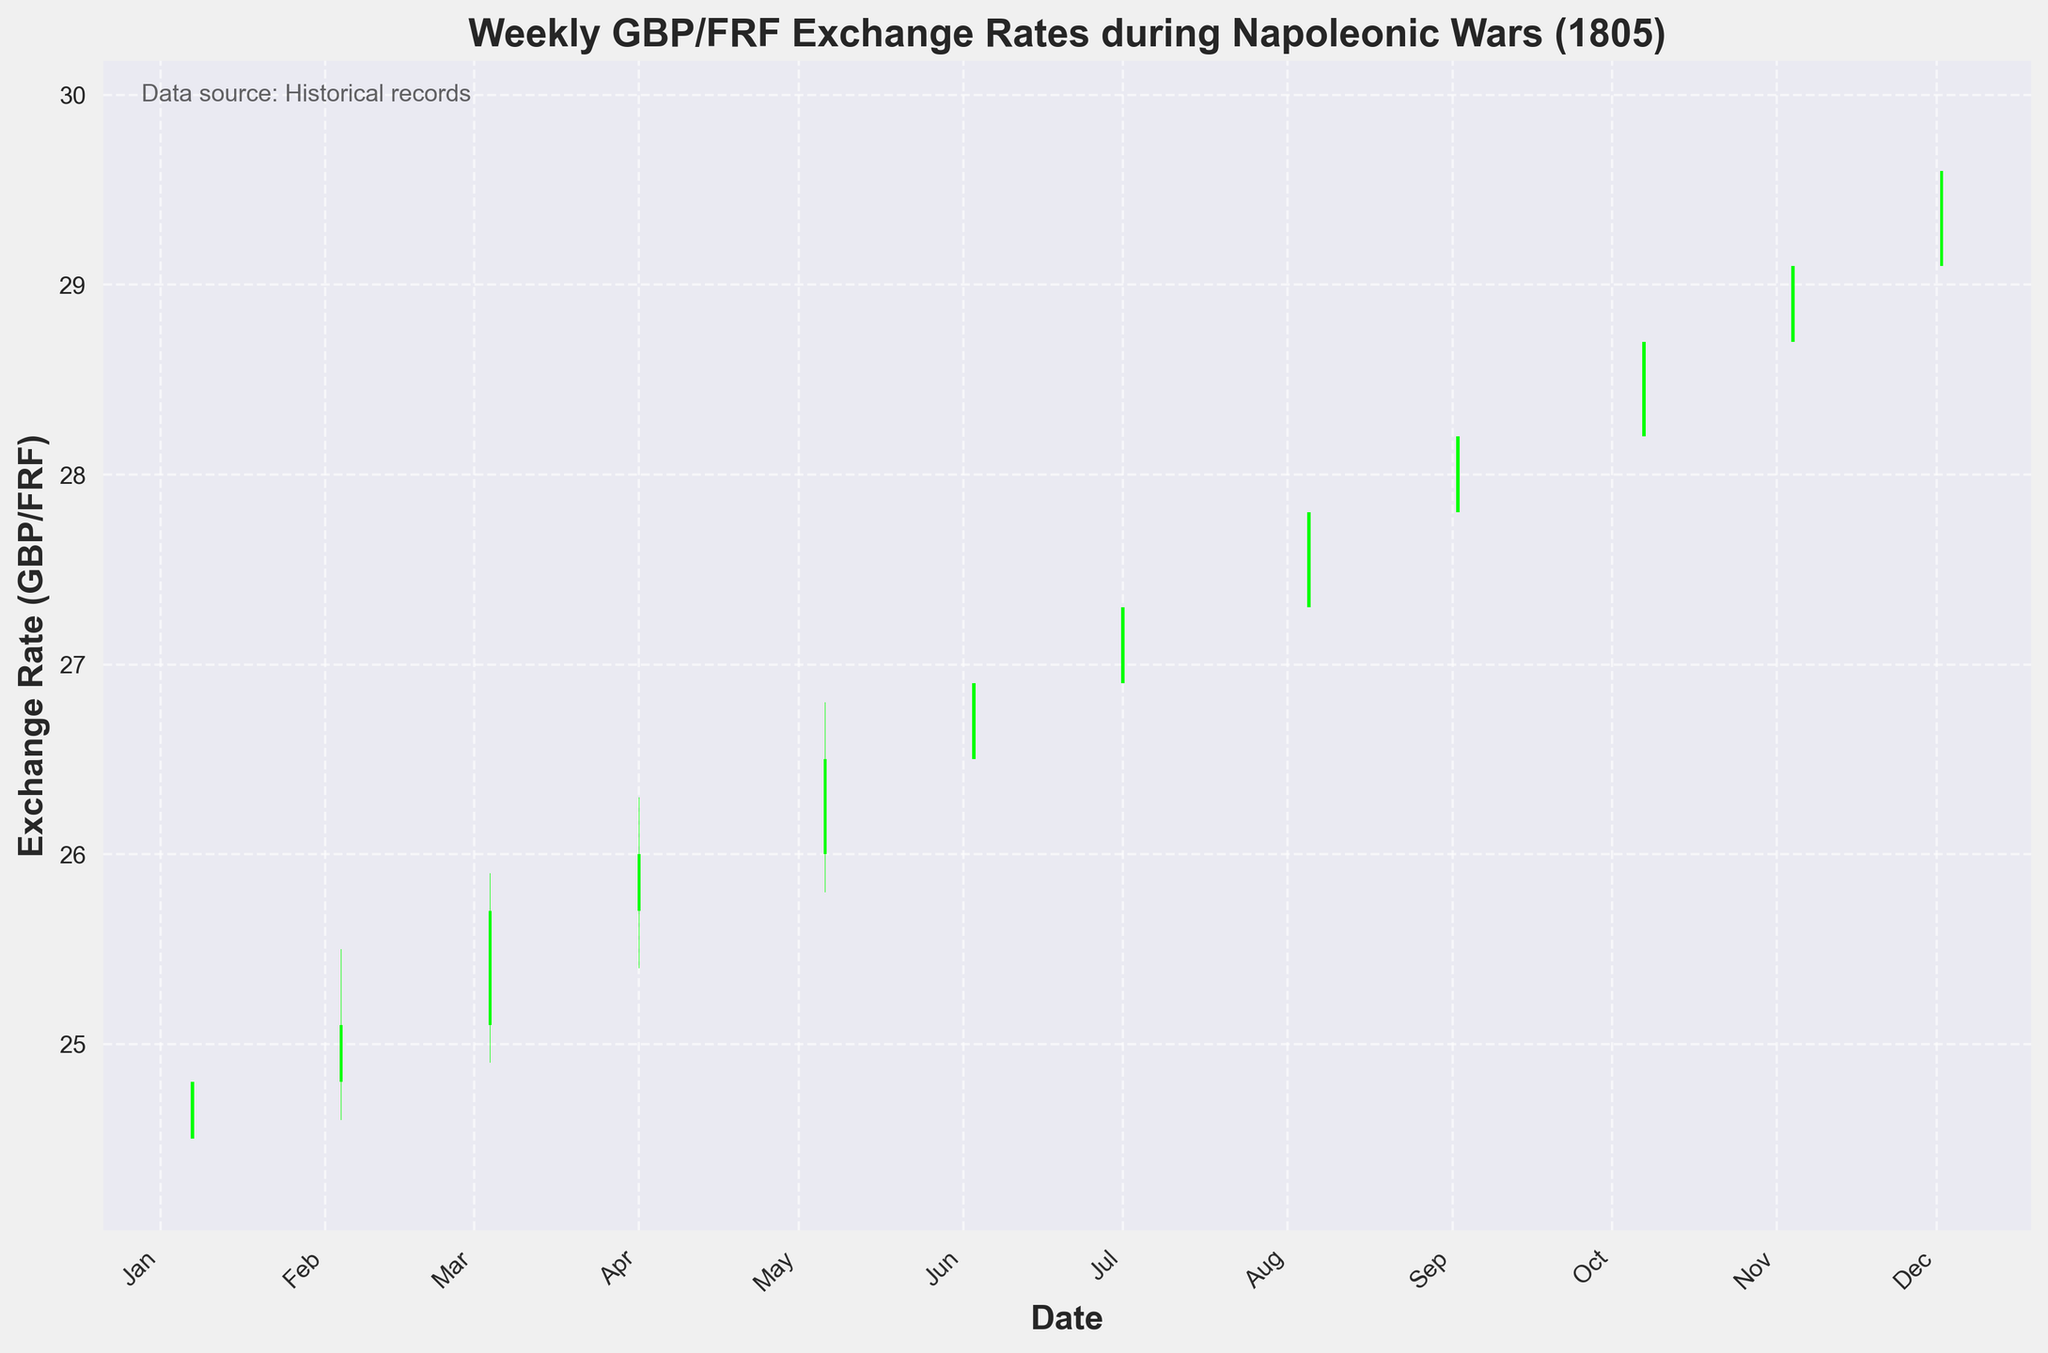What is the title of the figure? The title of the figure is written at the top and clearly refers to the data being displayed.
Answer: Weekly GBP/FRF Exchange Rates during Napoleonic Wars (1805) Which period does the data cover? The dates on the x-axis of the chart indicate the time period covered by the data.
Answer: January 1805 to December 1805 How many times did the Close value exceed the Open value? By visually inspecting the color of the bars — green for Close >= Open and red for Close < Open — we can count the green bars.
Answer: 11 times What was the highest exchange rate reached and in which month? By observing the highest point on the upper wick of the bars, we can identify the peak value and check the corresponding month on the x-axis.
Answer: 29.9 in December 1805 In which month did the exchange rate witness the highest volatility (difference between High and Low)? To find volatility, we need to check the difference between High and Low for each bar and identify the month with the maximum difference.
Answer: November 1805 How does the exchange rate trend from January to December 1805? By following the general direction of the Close values from January to December 1805, we can describe the trend.
Answer: Upward Trend What is the average Closing exchange rate in the second half of 1805? Sum the Closing values from July to December and then divide by the number of data points (6).
Answer: (27.3 + 27.8 + 28.2 + 28.7 + 29.1 + 29.6)/6 = 28.45 Was there any month where the Opening exchange rate was higher than the previous month's Closing rate? By comparing the Opening rate of each month with the previous month's Closing rate, we can identify any occurrences.
Answer: No, the Opening rate is always either equal to or lower than the previous month's Closing rate Which month had the smallest range between the High and Low values? Evaluate the difference between High and Low for each month, and find the month with the smallest difference.
Answer: January 1805 